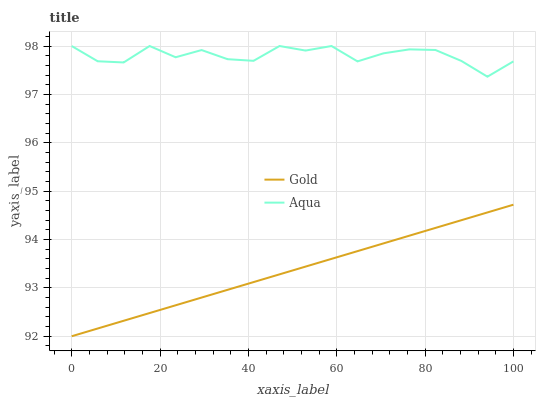Does Gold have the minimum area under the curve?
Answer yes or no. Yes. Does Aqua have the maximum area under the curve?
Answer yes or no. Yes. Does Gold have the maximum area under the curve?
Answer yes or no. No. Is Gold the smoothest?
Answer yes or no. Yes. Is Aqua the roughest?
Answer yes or no. Yes. Is Gold the roughest?
Answer yes or no. No. Does Gold have the lowest value?
Answer yes or no. Yes. Does Aqua have the highest value?
Answer yes or no. Yes. Does Gold have the highest value?
Answer yes or no. No. Is Gold less than Aqua?
Answer yes or no. Yes. Is Aqua greater than Gold?
Answer yes or no. Yes. Does Gold intersect Aqua?
Answer yes or no. No. 